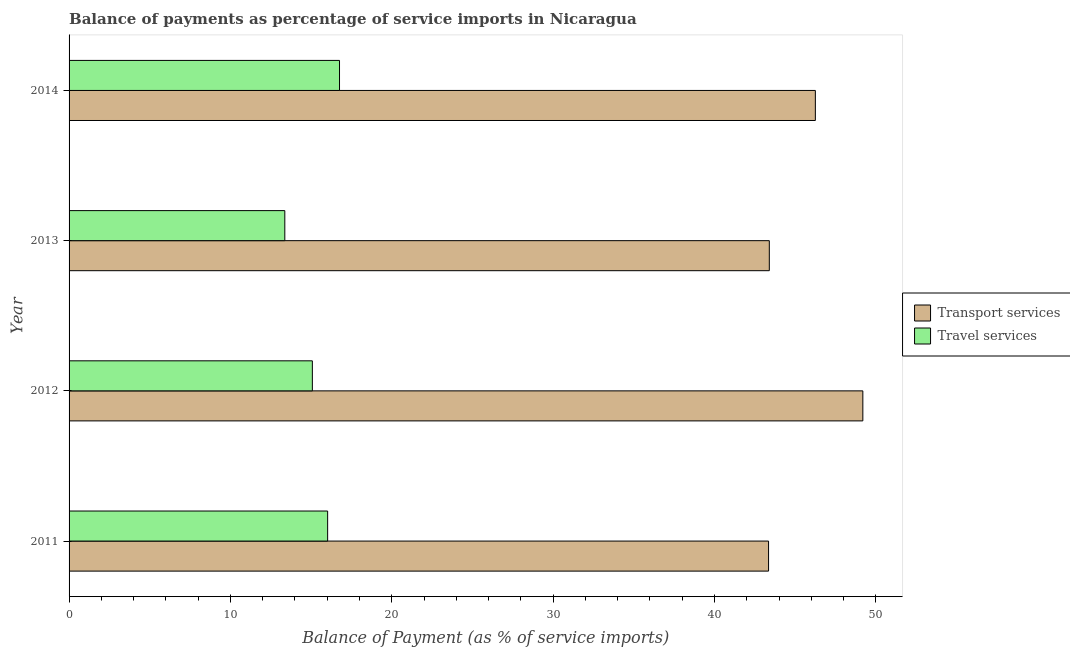How many different coloured bars are there?
Offer a very short reply. 2. How many groups of bars are there?
Your answer should be very brief. 4. Are the number of bars on each tick of the Y-axis equal?
Provide a succinct answer. Yes. How many bars are there on the 3rd tick from the bottom?
Offer a terse response. 2. What is the balance of payments of travel services in 2014?
Make the answer very short. 16.76. Across all years, what is the maximum balance of payments of transport services?
Offer a terse response. 49.2. Across all years, what is the minimum balance of payments of transport services?
Provide a succinct answer. 43.35. In which year was the balance of payments of travel services maximum?
Your answer should be compact. 2014. In which year was the balance of payments of transport services minimum?
Offer a terse response. 2011. What is the total balance of payments of travel services in the graph?
Ensure brevity in your answer.  61.24. What is the difference between the balance of payments of transport services in 2011 and that in 2013?
Your response must be concise. -0.05. What is the difference between the balance of payments of travel services in 2011 and the balance of payments of transport services in 2014?
Your response must be concise. -30.23. What is the average balance of payments of travel services per year?
Make the answer very short. 15.31. In the year 2011, what is the difference between the balance of payments of travel services and balance of payments of transport services?
Provide a short and direct response. -27.33. In how many years, is the balance of payments of transport services greater than 8 %?
Provide a succinct answer. 4. What is the ratio of the balance of payments of travel services in 2012 to that in 2013?
Your response must be concise. 1.13. Is the difference between the balance of payments of transport services in 2011 and 2014 greater than the difference between the balance of payments of travel services in 2011 and 2014?
Offer a very short reply. No. What is the difference between the highest and the second highest balance of payments of travel services?
Offer a very short reply. 0.74. What is the difference between the highest and the lowest balance of payments of transport services?
Make the answer very short. 5.84. In how many years, is the balance of payments of transport services greater than the average balance of payments of transport services taken over all years?
Ensure brevity in your answer.  2. Is the sum of the balance of payments of travel services in 2012 and 2013 greater than the maximum balance of payments of transport services across all years?
Ensure brevity in your answer.  No. What does the 1st bar from the top in 2012 represents?
Ensure brevity in your answer.  Travel services. What does the 1st bar from the bottom in 2013 represents?
Your response must be concise. Transport services. How many bars are there?
Offer a terse response. 8. Are all the bars in the graph horizontal?
Give a very brief answer. Yes. What is the difference between two consecutive major ticks on the X-axis?
Offer a terse response. 10. Are the values on the major ticks of X-axis written in scientific E-notation?
Provide a succinct answer. No. Does the graph contain grids?
Keep it short and to the point. No. How many legend labels are there?
Offer a terse response. 2. How are the legend labels stacked?
Offer a very short reply. Vertical. What is the title of the graph?
Your response must be concise. Balance of payments as percentage of service imports in Nicaragua. What is the label or title of the X-axis?
Ensure brevity in your answer.  Balance of Payment (as % of service imports). What is the label or title of the Y-axis?
Keep it short and to the point. Year. What is the Balance of Payment (as % of service imports) of Transport services in 2011?
Your answer should be very brief. 43.35. What is the Balance of Payment (as % of service imports) in Travel services in 2011?
Provide a succinct answer. 16.03. What is the Balance of Payment (as % of service imports) in Transport services in 2012?
Provide a succinct answer. 49.2. What is the Balance of Payment (as % of service imports) in Travel services in 2012?
Your response must be concise. 15.08. What is the Balance of Payment (as % of service imports) of Transport services in 2013?
Your answer should be compact. 43.4. What is the Balance of Payment (as % of service imports) in Travel services in 2013?
Your answer should be compact. 13.37. What is the Balance of Payment (as % of service imports) in Transport services in 2014?
Offer a very short reply. 46.25. What is the Balance of Payment (as % of service imports) of Travel services in 2014?
Offer a very short reply. 16.76. Across all years, what is the maximum Balance of Payment (as % of service imports) of Transport services?
Offer a terse response. 49.2. Across all years, what is the maximum Balance of Payment (as % of service imports) of Travel services?
Your answer should be compact. 16.76. Across all years, what is the minimum Balance of Payment (as % of service imports) of Transport services?
Make the answer very short. 43.35. Across all years, what is the minimum Balance of Payment (as % of service imports) in Travel services?
Offer a terse response. 13.37. What is the total Balance of Payment (as % of service imports) in Transport services in the graph?
Make the answer very short. 182.2. What is the total Balance of Payment (as % of service imports) of Travel services in the graph?
Ensure brevity in your answer.  61.24. What is the difference between the Balance of Payment (as % of service imports) of Transport services in 2011 and that in 2012?
Keep it short and to the point. -5.84. What is the difference between the Balance of Payment (as % of service imports) in Transport services in 2011 and that in 2013?
Provide a succinct answer. -0.05. What is the difference between the Balance of Payment (as % of service imports) in Travel services in 2011 and that in 2013?
Keep it short and to the point. 2.65. What is the difference between the Balance of Payment (as % of service imports) in Transport services in 2011 and that in 2014?
Provide a short and direct response. -2.9. What is the difference between the Balance of Payment (as % of service imports) in Travel services in 2011 and that in 2014?
Give a very brief answer. -0.74. What is the difference between the Balance of Payment (as % of service imports) in Transport services in 2012 and that in 2013?
Offer a very short reply. 5.8. What is the difference between the Balance of Payment (as % of service imports) in Travel services in 2012 and that in 2013?
Keep it short and to the point. 1.71. What is the difference between the Balance of Payment (as % of service imports) in Transport services in 2012 and that in 2014?
Your answer should be very brief. 2.94. What is the difference between the Balance of Payment (as % of service imports) in Travel services in 2012 and that in 2014?
Offer a very short reply. -1.68. What is the difference between the Balance of Payment (as % of service imports) of Transport services in 2013 and that in 2014?
Provide a short and direct response. -2.85. What is the difference between the Balance of Payment (as % of service imports) in Travel services in 2013 and that in 2014?
Give a very brief answer. -3.39. What is the difference between the Balance of Payment (as % of service imports) in Transport services in 2011 and the Balance of Payment (as % of service imports) in Travel services in 2012?
Offer a terse response. 28.27. What is the difference between the Balance of Payment (as % of service imports) in Transport services in 2011 and the Balance of Payment (as % of service imports) in Travel services in 2013?
Your answer should be very brief. 29.98. What is the difference between the Balance of Payment (as % of service imports) of Transport services in 2011 and the Balance of Payment (as % of service imports) of Travel services in 2014?
Offer a very short reply. 26.59. What is the difference between the Balance of Payment (as % of service imports) of Transport services in 2012 and the Balance of Payment (as % of service imports) of Travel services in 2013?
Provide a succinct answer. 35.83. What is the difference between the Balance of Payment (as % of service imports) in Transport services in 2012 and the Balance of Payment (as % of service imports) in Travel services in 2014?
Provide a succinct answer. 32.43. What is the difference between the Balance of Payment (as % of service imports) in Transport services in 2013 and the Balance of Payment (as % of service imports) in Travel services in 2014?
Offer a very short reply. 26.64. What is the average Balance of Payment (as % of service imports) in Transport services per year?
Give a very brief answer. 45.55. What is the average Balance of Payment (as % of service imports) of Travel services per year?
Make the answer very short. 15.31. In the year 2011, what is the difference between the Balance of Payment (as % of service imports) of Transport services and Balance of Payment (as % of service imports) of Travel services?
Offer a terse response. 27.33. In the year 2012, what is the difference between the Balance of Payment (as % of service imports) in Transport services and Balance of Payment (as % of service imports) in Travel services?
Provide a short and direct response. 34.12. In the year 2013, what is the difference between the Balance of Payment (as % of service imports) in Transport services and Balance of Payment (as % of service imports) in Travel services?
Keep it short and to the point. 30.03. In the year 2014, what is the difference between the Balance of Payment (as % of service imports) in Transport services and Balance of Payment (as % of service imports) in Travel services?
Keep it short and to the point. 29.49. What is the ratio of the Balance of Payment (as % of service imports) in Transport services in 2011 to that in 2012?
Give a very brief answer. 0.88. What is the ratio of the Balance of Payment (as % of service imports) of Travel services in 2011 to that in 2012?
Make the answer very short. 1.06. What is the ratio of the Balance of Payment (as % of service imports) of Travel services in 2011 to that in 2013?
Your answer should be very brief. 1.2. What is the ratio of the Balance of Payment (as % of service imports) in Transport services in 2011 to that in 2014?
Give a very brief answer. 0.94. What is the ratio of the Balance of Payment (as % of service imports) in Travel services in 2011 to that in 2014?
Make the answer very short. 0.96. What is the ratio of the Balance of Payment (as % of service imports) in Transport services in 2012 to that in 2013?
Provide a succinct answer. 1.13. What is the ratio of the Balance of Payment (as % of service imports) in Travel services in 2012 to that in 2013?
Give a very brief answer. 1.13. What is the ratio of the Balance of Payment (as % of service imports) in Transport services in 2012 to that in 2014?
Provide a succinct answer. 1.06. What is the ratio of the Balance of Payment (as % of service imports) of Travel services in 2012 to that in 2014?
Your answer should be very brief. 0.9. What is the ratio of the Balance of Payment (as % of service imports) of Transport services in 2013 to that in 2014?
Your response must be concise. 0.94. What is the ratio of the Balance of Payment (as % of service imports) in Travel services in 2013 to that in 2014?
Provide a short and direct response. 0.8. What is the difference between the highest and the second highest Balance of Payment (as % of service imports) of Transport services?
Give a very brief answer. 2.94. What is the difference between the highest and the second highest Balance of Payment (as % of service imports) in Travel services?
Offer a very short reply. 0.74. What is the difference between the highest and the lowest Balance of Payment (as % of service imports) in Transport services?
Your response must be concise. 5.84. What is the difference between the highest and the lowest Balance of Payment (as % of service imports) of Travel services?
Ensure brevity in your answer.  3.39. 